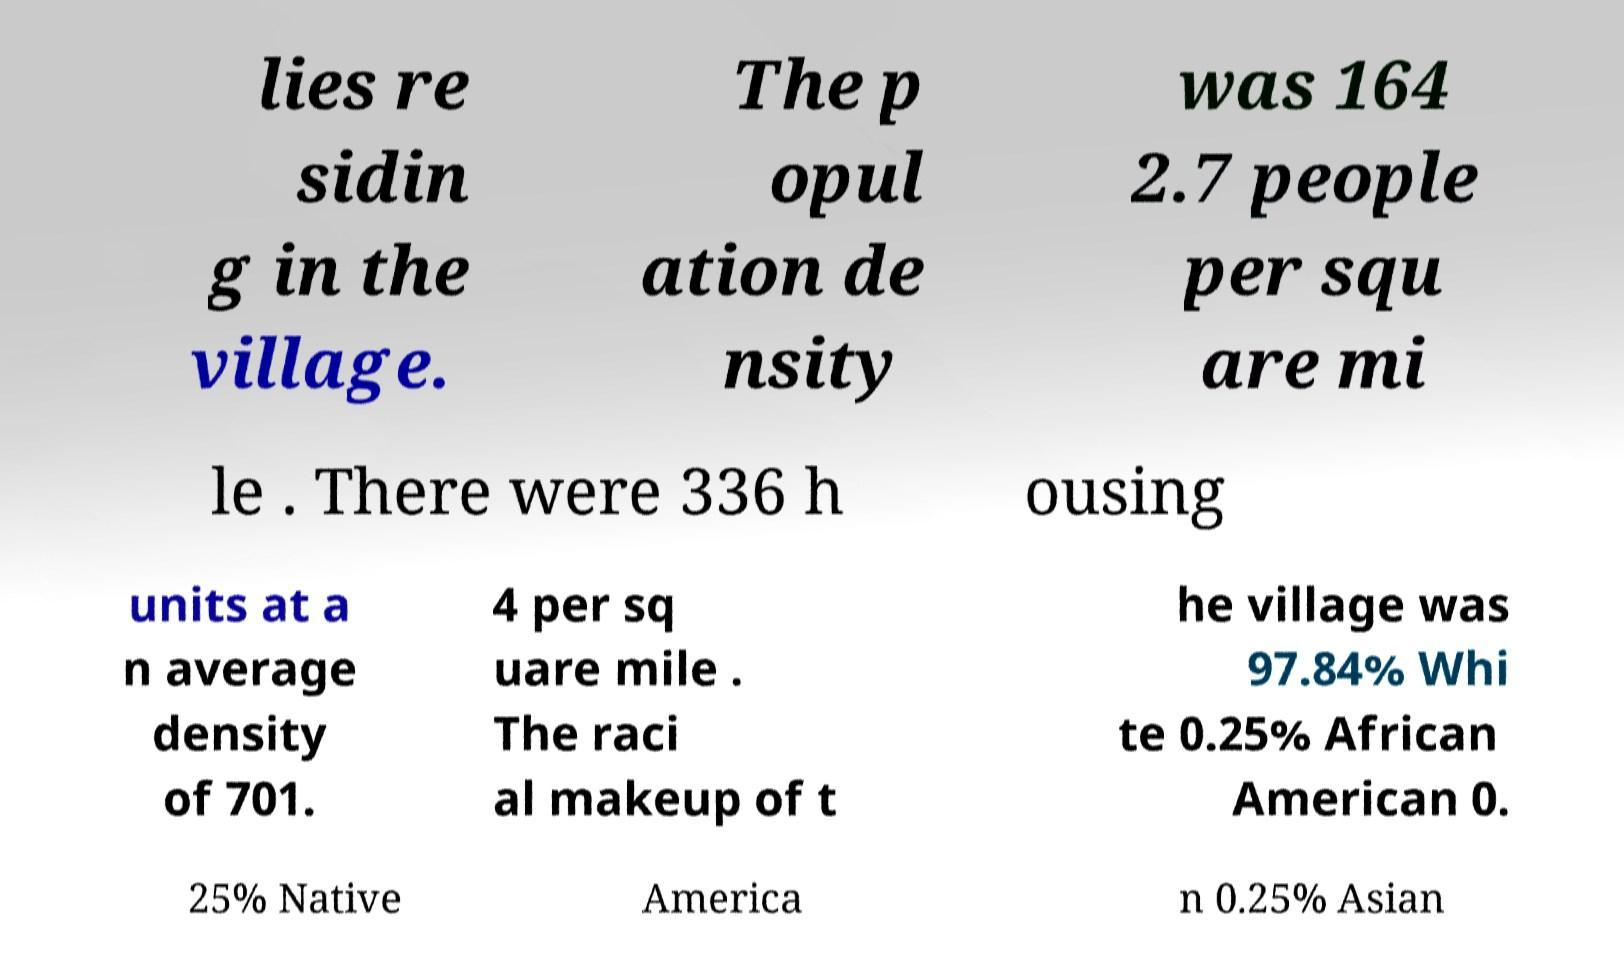Could you assist in decoding the text presented in this image and type it out clearly? lies re sidin g in the village. The p opul ation de nsity was 164 2.7 people per squ are mi le . There were 336 h ousing units at a n average density of 701. 4 per sq uare mile . The raci al makeup of t he village was 97.84% Whi te 0.25% African American 0. 25% Native America n 0.25% Asian 